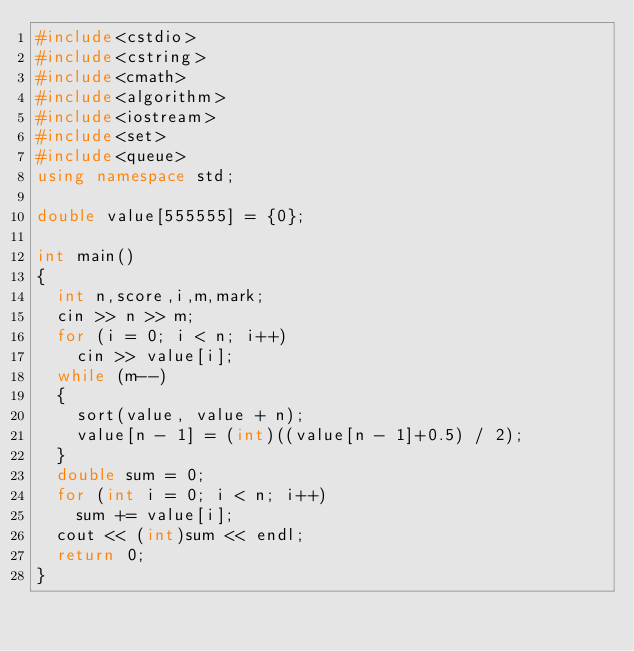<code> <loc_0><loc_0><loc_500><loc_500><_C++_>#include<cstdio>
#include<cstring>
#include<cmath>
#include<algorithm>
#include<iostream>
#include<set>
#include<queue>
using namespace std;

double value[555555] = {0};

int main() 
{
	int n,score,i,m,mark;
	cin >> n >> m;
	for (i = 0; i < n; i++)
		cin >> value[i];
	while (m--)
	{
		sort(value, value + n);
		value[n - 1] = (int)((value[n - 1]+0.5) / 2);
	}
	double sum = 0;
	for (int i = 0; i < n; i++)
		sum += value[i];
	cout << (int)sum << endl;
	return 0;
}</code> 